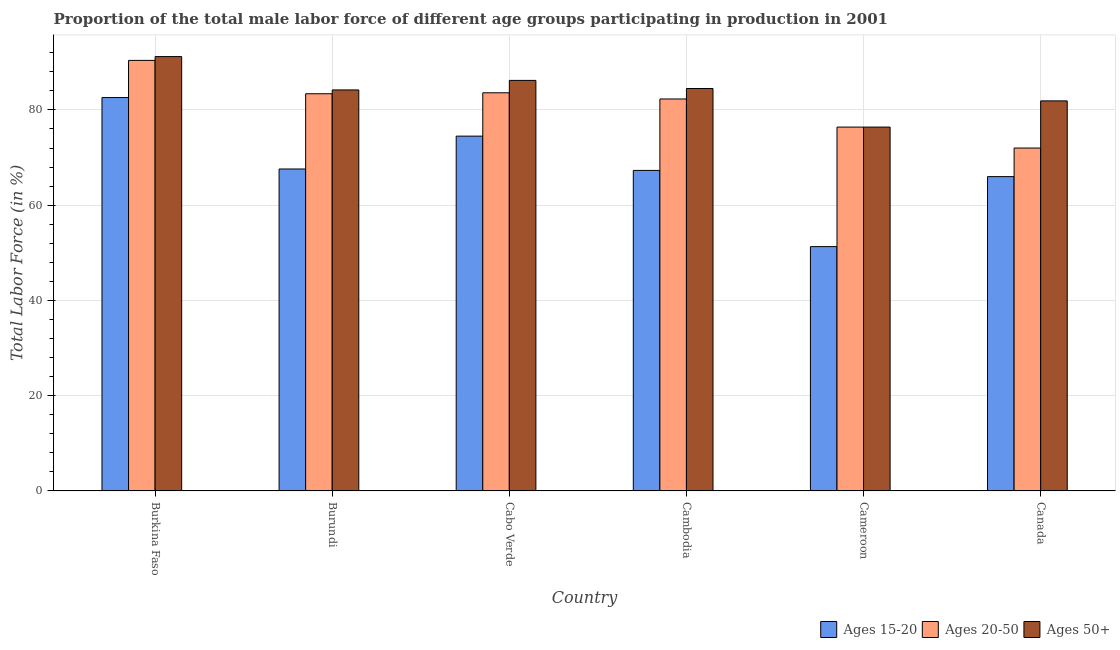How many groups of bars are there?
Provide a short and direct response. 6. What is the label of the 2nd group of bars from the left?
Keep it short and to the point. Burundi. In how many cases, is the number of bars for a given country not equal to the number of legend labels?
Ensure brevity in your answer.  0. What is the percentage of male labor force within the age group 15-20 in Cameroon?
Your answer should be very brief. 51.3. Across all countries, what is the maximum percentage of male labor force within the age group 15-20?
Offer a very short reply. 82.6. In which country was the percentage of male labor force within the age group 20-50 maximum?
Keep it short and to the point. Burkina Faso. In which country was the percentage of male labor force within the age group 15-20 minimum?
Keep it short and to the point. Cameroon. What is the total percentage of male labor force within the age group 20-50 in the graph?
Give a very brief answer. 488.1. What is the difference between the percentage of male labor force within the age group 15-20 in Burundi and that in Cameroon?
Offer a terse response. 16.3. What is the difference between the percentage of male labor force within the age group 15-20 in Burundi and the percentage of male labor force above age 50 in Cameroon?
Ensure brevity in your answer.  -8.8. What is the average percentage of male labor force within the age group 15-20 per country?
Ensure brevity in your answer.  68.22. What is the difference between the percentage of male labor force above age 50 and percentage of male labor force within the age group 15-20 in Canada?
Offer a very short reply. 15.9. In how many countries, is the percentage of male labor force within the age group 15-20 greater than 20 %?
Your answer should be compact. 6. What is the ratio of the percentage of male labor force within the age group 15-20 in Cameroon to that in Canada?
Offer a terse response. 0.78. What is the difference between the highest and the lowest percentage of male labor force above age 50?
Ensure brevity in your answer.  14.8. What does the 3rd bar from the left in Burkina Faso represents?
Keep it short and to the point. Ages 50+. What does the 2nd bar from the right in Canada represents?
Ensure brevity in your answer.  Ages 20-50. Is it the case that in every country, the sum of the percentage of male labor force within the age group 15-20 and percentage of male labor force within the age group 20-50 is greater than the percentage of male labor force above age 50?
Offer a very short reply. Yes. How many bars are there?
Provide a succinct answer. 18. What is the difference between two consecutive major ticks on the Y-axis?
Ensure brevity in your answer.  20. Where does the legend appear in the graph?
Your response must be concise. Bottom right. What is the title of the graph?
Provide a short and direct response. Proportion of the total male labor force of different age groups participating in production in 2001. Does "Unemployment benefits" appear as one of the legend labels in the graph?
Provide a succinct answer. No. What is the label or title of the X-axis?
Your answer should be very brief. Country. What is the label or title of the Y-axis?
Your answer should be very brief. Total Labor Force (in %). What is the Total Labor Force (in %) in Ages 15-20 in Burkina Faso?
Your answer should be very brief. 82.6. What is the Total Labor Force (in %) of Ages 20-50 in Burkina Faso?
Give a very brief answer. 90.4. What is the Total Labor Force (in %) of Ages 50+ in Burkina Faso?
Offer a terse response. 91.2. What is the Total Labor Force (in %) in Ages 15-20 in Burundi?
Keep it short and to the point. 67.6. What is the Total Labor Force (in %) in Ages 20-50 in Burundi?
Make the answer very short. 83.4. What is the Total Labor Force (in %) of Ages 50+ in Burundi?
Your response must be concise. 84.2. What is the Total Labor Force (in %) of Ages 15-20 in Cabo Verde?
Provide a short and direct response. 74.5. What is the Total Labor Force (in %) in Ages 20-50 in Cabo Verde?
Your answer should be very brief. 83.6. What is the Total Labor Force (in %) of Ages 50+ in Cabo Verde?
Provide a succinct answer. 86.2. What is the Total Labor Force (in %) in Ages 15-20 in Cambodia?
Offer a terse response. 67.3. What is the Total Labor Force (in %) of Ages 20-50 in Cambodia?
Ensure brevity in your answer.  82.3. What is the Total Labor Force (in %) of Ages 50+ in Cambodia?
Provide a succinct answer. 84.5. What is the Total Labor Force (in %) of Ages 15-20 in Cameroon?
Your answer should be compact. 51.3. What is the Total Labor Force (in %) in Ages 20-50 in Cameroon?
Your response must be concise. 76.4. What is the Total Labor Force (in %) in Ages 50+ in Cameroon?
Ensure brevity in your answer.  76.4. What is the Total Labor Force (in %) in Ages 20-50 in Canada?
Provide a succinct answer. 72. What is the Total Labor Force (in %) in Ages 50+ in Canada?
Your answer should be very brief. 81.9. Across all countries, what is the maximum Total Labor Force (in %) in Ages 15-20?
Make the answer very short. 82.6. Across all countries, what is the maximum Total Labor Force (in %) in Ages 20-50?
Your response must be concise. 90.4. Across all countries, what is the maximum Total Labor Force (in %) of Ages 50+?
Keep it short and to the point. 91.2. Across all countries, what is the minimum Total Labor Force (in %) in Ages 15-20?
Make the answer very short. 51.3. Across all countries, what is the minimum Total Labor Force (in %) of Ages 50+?
Your answer should be compact. 76.4. What is the total Total Labor Force (in %) of Ages 15-20 in the graph?
Offer a terse response. 409.3. What is the total Total Labor Force (in %) of Ages 20-50 in the graph?
Your answer should be compact. 488.1. What is the total Total Labor Force (in %) of Ages 50+ in the graph?
Provide a short and direct response. 504.4. What is the difference between the Total Labor Force (in %) of Ages 15-20 in Burkina Faso and that in Burundi?
Provide a short and direct response. 15. What is the difference between the Total Labor Force (in %) in Ages 50+ in Burkina Faso and that in Burundi?
Provide a short and direct response. 7. What is the difference between the Total Labor Force (in %) of Ages 15-20 in Burkina Faso and that in Cabo Verde?
Give a very brief answer. 8.1. What is the difference between the Total Labor Force (in %) of Ages 20-50 in Burkina Faso and that in Cabo Verde?
Give a very brief answer. 6.8. What is the difference between the Total Labor Force (in %) of Ages 15-20 in Burkina Faso and that in Cameroon?
Keep it short and to the point. 31.3. What is the difference between the Total Labor Force (in %) in Ages 20-50 in Burkina Faso and that in Cameroon?
Ensure brevity in your answer.  14. What is the difference between the Total Labor Force (in %) of Ages 15-20 in Burkina Faso and that in Canada?
Offer a terse response. 16.6. What is the difference between the Total Labor Force (in %) of Ages 50+ in Burkina Faso and that in Canada?
Make the answer very short. 9.3. What is the difference between the Total Labor Force (in %) of Ages 20-50 in Burundi and that in Cabo Verde?
Your response must be concise. -0.2. What is the difference between the Total Labor Force (in %) in Ages 50+ in Burundi and that in Cabo Verde?
Provide a succinct answer. -2. What is the difference between the Total Labor Force (in %) of Ages 20-50 in Burundi and that in Cambodia?
Your answer should be very brief. 1.1. What is the difference between the Total Labor Force (in %) of Ages 50+ in Burundi and that in Cambodia?
Your answer should be very brief. -0.3. What is the difference between the Total Labor Force (in %) of Ages 20-50 in Burundi and that in Cameroon?
Provide a short and direct response. 7. What is the difference between the Total Labor Force (in %) in Ages 50+ in Burundi and that in Cameroon?
Your response must be concise. 7.8. What is the difference between the Total Labor Force (in %) of Ages 20-50 in Burundi and that in Canada?
Your answer should be compact. 11.4. What is the difference between the Total Labor Force (in %) in Ages 20-50 in Cabo Verde and that in Cambodia?
Your response must be concise. 1.3. What is the difference between the Total Labor Force (in %) of Ages 50+ in Cabo Verde and that in Cambodia?
Your response must be concise. 1.7. What is the difference between the Total Labor Force (in %) of Ages 15-20 in Cabo Verde and that in Cameroon?
Give a very brief answer. 23.2. What is the difference between the Total Labor Force (in %) in Ages 20-50 in Cabo Verde and that in Cameroon?
Your answer should be very brief. 7.2. What is the difference between the Total Labor Force (in %) in Ages 15-20 in Cabo Verde and that in Canada?
Keep it short and to the point. 8.5. What is the difference between the Total Labor Force (in %) of Ages 20-50 in Cabo Verde and that in Canada?
Your answer should be compact. 11.6. What is the difference between the Total Labor Force (in %) in Ages 50+ in Cambodia and that in Cameroon?
Provide a short and direct response. 8.1. What is the difference between the Total Labor Force (in %) of Ages 15-20 in Cambodia and that in Canada?
Ensure brevity in your answer.  1.3. What is the difference between the Total Labor Force (in %) in Ages 50+ in Cambodia and that in Canada?
Offer a very short reply. 2.6. What is the difference between the Total Labor Force (in %) in Ages 15-20 in Cameroon and that in Canada?
Give a very brief answer. -14.7. What is the difference between the Total Labor Force (in %) in Ages 50+ in Cameroon and that in Canada?
Provide a succinct answer. -5.5. What is the difference between the Total Labor Force (in %) in Ages 15-20 in Burkina Faso and the Total Labor Force (in %) in Ages 20-50 in Burundi?
Your answer should be very brief. -0.8. What is the difference between the Total Labor Force (in %) in Ages 20-50 in Burkina Faso and the Total Labor Force (in %) in Ages 50+ in Burundi?
Your response must be concise. 6.2. What is the difference between the Total Labor Force (in %) of Ages 15-20 in Burkina Faso and the Total Labor Force (in %) of Ages 50+ in Cabo Verde?
Keep it short and to the point. -3.6. What is the difference between the Total Labor Force (in %) of Ages 15-20 in Burkina Faso and the Total Labor Force (in %) of Ages 50+ in Cambodia?
Your answer should be very brief. -1.9. What is the difference between the Total Labor Force (in %) of Ages 20-50 in Burkina Faso and the Total Labor Force (in %) of Ages 50+ in Cambodia?
Provide a succinct answer. 5.9. What is the difference between the Total Labor Force (in %) in Ages 15-20 in Burkina Faso and the Total Labor Force (in %) in Ages 20-50 in Cameroon?
Give a very brief answer. 6.2. What is the difference between the Total Labor Force (in %) of Ages 15-20 in Burkina Faso and the Total Labor Force (in %) of Ages 50+ in Cameroon?
Your answer should be very brief. 6.2. What is the difference between the Total Labor Force (in %) in Ages 20-50 in Burkina Faso and the Total Labor Force (in %) in Ages 50+ in Cameroon?
Your answer should be very brief. 14. What is the difference between the Total Labor Force (in %) in Ages 15-20 in Burkina Faso and the Total Labor Force (in %) in Ages 20-50 in Canada?
Your answer should be compact. 10.6. What is the difference between the Total Labor Force (in %) of Ages 15-20 in Burkina Faso and the Total Labor Force (in %) of Ages 50+ in Canada?
Offer a terse response. 0.7. What is the difference between the Total Labor Force (in %) in Ages 20-50 in Burkina Faso and the Total Labor Force (in %) in Ages 50+ in Canada?
Offer a very short reply. 8.5. What is the difference between the Total Labor Force (in %) in Ages 15-20 in Burundi and the Total Labor Force (in %) in Ages 50+ in Cabo Verde?
Offer a very short reply. -18.6. What is the difference between the Total Labor Force (in %) of Ages 20-50 in Burundi and the Total Labor Force (in %) of Ages 50+ in Cabo Verde?
Make the answer very short. -2.8. What is the difference between the Total Labor Force (in %) of Ages 15-20 in Burundi and the Total Labor Force (in %) of Ages 20-50 in Cambodia?
Provide a succinct answer. -14.7. What is the difference between the Total Labor Force (in %) of Ages 15-20 in Burundi and the Total Labor Force (in %) of Ages 50+ in Cambodia?
Provide a short and direct response. -16.9. What is the difference between the Total Labor Force (in %) of Ages 20-50 in Burundi and the Total Labor Force (in %) of Ages 50+ in Cameroon?
Provide a succinct answer. 7. What is the difference between the Total Labor Force (in %) of Ages 15-20 in Burundi and the Total Labor Force (in %) of Ages 50+ in Canada?
Offer a very short reply. -14.3. What is the difference between the Total Labor Force (in %) of Ages 15-20 in Cabo Verde and the Total Labor Force (in %) of Ages 50+ in Cambodia?
Make the answer very short. -10. What is the difference between the Total Labor Force (in %) in Ages 15-20 in Cabo Verde and the Total Labor Force (in %) in Ages 50+ in Cameroon?
Offer a very short reply. -1.9. What is the difference between the Total Labor Force (in %) of Ages 20-50 in Cabo Verde and the Total Labor Force (in %) of Ages 50+ in Cameroon?
Provide a succinct answer. 7.2. What is the difference between the Total Labor Force (in %) in Ages 15-20 in Cabo Verde and the Total Labor Force (in %) in Ages 20-50 in Canada?
Ensure brevity in your answer.  2.5. What is the difference between the Total Labor Force (in %) of Ages 15-20 in Cabo Verde and the Total Labor Force (in %) of Ages 50+ in Canada?
Give a very brief answer. -7.4. What is the difference between the Total Labor Force (in %) of Ages 20-50 in Cabo Verde and the Total Labor Force (in %) of Ages 50+ in Canada?
Offer a terse response. 1.7. What is the difference between the Total Labor Force (in %) in Ages 15-20 in Cambodia and the Total Labor Force (in %) in Ages 50+ in Cameroon?
Offer a terse response. -9.1. What is the difference between the Total Labor Force (in %) of Ages 20-50 in Cambodia and the Total Labor Force (in %) of Ages 50+ in Cameroon?
Your response must be concise. 5.9. What is the difference between the Total Labor Force (in %) in Ages 15-20 in Cambodia and the Total Labor Force (in %) in Ages 20-50 in Canada?
Make the answer very short. -4.7. What is the difference between the Total Labor Force (in %) of Ages 15-20 in Cambodia and the Total Labor Force (in %) of Ages 50+ in Canada?
Give a very brief answer. -14.6. What is the difference between the Total Labor Force (in %) of Ages 20-50 in Cambodia and the Total Labor Force (in %) of Ages 50+ in Canada?
Provide a short and direct response. 0.4. What is the difference between the Total Labor Force (in %) in Ages 15-20 in Cameroon and the Total Labor Force (in %) in Ages 20-50 in Canada?
Your answer should be very brief. -20.7. What is the difference between the Total Labor Force (in %) of Ages 15-20 in Cameroon and the Total Labor Force (in %) of Ages 50+ in Canada?
Your answer should be very brief. -30.6. What is the average Total Labor Force (in %) of Ages 15-20 per country?
Provide a succinct answer. 68.22. What is the average Total Labor Force (in %) in Ages 20-50 per country?
Give a very brief answer. 81.35. What is the average Total Labor Force (in %) of Ages 50+ per country?
Your answer should be compact. 84.07. What is the difference between the Total Labor Force (in %) in Ages 15-20 and Total Labor Force (in %) in Ages 50+ in Burkina Faso?
Provide a short and direct response. -8.6. What is the difference between the Total Labor Force (in %) of Ages 20-50 and Total Labor Force (in %) of Ages 50+ in Burkina Faso?
Provide a succinct answer. -0.8. What is the difference between the Total Labor Force (in %) of Ages 15-20 and Total Labor Force (in %) of Ages 20-50 in Burundi?
Ensure brevity in your answer.  -15.8. What is the difference between the Total Labor Force (in %) of Ages 15-20 and Total Labor Force (in %) of Ages 50+ in Burundi?
Your response must be concise. -16.6. What is the difference between the Total Labor Force (in %) of Ages 20-50 and Total Labor Force (in %) of Ages 50+ in Cabo Verde?
Provide a short and direct response. -2.6. What is the difference between the Total Labor Force (in %) of Ages 15-20 and Total Labor Force (in %) of Ages 50+ in Cambodia?
Offer a terse response. -17.2. What is the difference between the Total Labor Force (in %) in Ages 20-50 and Total Labor Force (in %) in Ages 50+ in Cambodia?
Your response must be concise. -2.2. What is the difference between the Total Labor Force (in %) in Ages 15-20 and Total Labor Force (in %) in Ages 20-50 in Cameroon?
Offer a terse response. -25.1. What is the difference between the Total Labor Force (in %) in Ages 15-20 and Total Labor Force (in %) in Ages 50+ in Cameroon?
Your answer should be compact. -25.1. What is the difference between the Total Labor Force (in %) of Ages 15-20 and Total Labor Force (in %) of Ages 50+ in Canada?
Make the answer very short. -15.9. What is the ratio of the Total Labor Force (in %) in Ages 15-20 in Burkina Faso to that in Burundi?
Give a very brief answer. 1.22. What is the ratio of the Total Labor Force (in %) of Ages 20-50 in Burkina Faso to that in Burundi?
Provide a short and direct response. 1.08. What is the ratio of the Total Labor Force (in %) in Ages 50+ in Burkina Faso to that in Burundi?
Offer a terse response. 1.08. What is the ratio of the Total Labor Force (in %) of Ages 15-20 in Burkina Faso to that in Cabo Verde?
Ensure brevity in your answer.  1.11. What is the ratio of the Total Labor Force (in %) of Ages 20-50 in Burkina Faso to that in Cabo Verde?
Make the answer very short. 1.08. What is the ratio of the Total Labor Force (in %) of Ages 50+ in Burkina Faso to that in Cabo Verde?
Make the answer very short. 1.06. What is the ratio of the Total Labor Force (in %) in Ages 15-20 in Burkina Faso to that in Cambodia?
Offer a terse response. 1.23. What is the ratio of the Total Labor Force (in %) in Ages 20-50 in Burkina Faso to that in Cambodia?
Give a very brief answer. 1.1. What is the ratio of the Total Labor Force (in %) in Ages 50+ in Burkina Faso to that in Cambodia?
Provide a short and direct response. 1.08. What is the ratio of the Total Labor Force (in %) of Ages 15-20 in Burkina Faso to that in Cameroon?
Offer a terse response. 1.61. What is the ratio of the Total Labor Force (in %) of Ages 20-50 in Burkina Faso to that in Cameroon?
Your response must be concise. 1.18. What is the ratio of the Total Labor Force (in %) of Ages 50+ in Burkina Faso to that in Cameroon?
Your answer should be very brief. 1.19. What is the ratio of the Total Labor Force (in %) in Ages 15-20 in Burkina Faso to that in Canada?
Provide a succinct answer. 1.25. What is the ratio of the Total Labor Force (in %) of Ages 20-50 in Burkina Faso to that in Canada?
Your answer should be compact. 1.26. What is the ratio of the Total Labor Force (in %) of Ages 50+ in Burkina Faso to that in Canada?
Your answer should be compact. 1.11. What is the ratio of the Total Labor Force (in %) in Ages 15-20 in Burundi to that in Cabo Verde?
Your answer should be compact. 0.91. What is the ratio of the Total Labor Force (in %) in Ages 20-50 in Burundi to that in Cabo Verde?
Keep it short and to the point. 1. What is the ratio of the Total Labor Force (in %) in Ages 50+ in Burundi to that in Cabo Verde?
Provide a short and direct response. 0.98. What is the ratio of the Total Labor Force (in %) in Ages 20-50 in Burundi to that in Cambodia?
Your response must be concise. 1.01. What is the ratio of the Total Labor Force (in %) in Ages 15-20 in Burundi to that in Cameroon?
Keep it short and to the point. 1.32. What is the ratio of the Total Labor Force (in %) in Ages 20-50 in Burundi to that in Cameroon?
Keep it short and to the point. 1.09. What is the ratio of the Total Labor Force (in %) of Ages 50+ in Burundi to that in Cameroon?
Keep it short and to the point. 1.1. What is the ratio of the Total Labor Force (in %) in Ages 15-20 in Burundi to that in Canada?
Provide a short and direct response. 1.02. What is the ratio of the Total Labor Force (in %) of Ages 20-50 in Burundi to that in Canada?
Keep it short and to the point. 1.16. What is the ratio of the Total Labor Force (in %) of Ages 50+ in Burundi to that in Canada?
Give a very brief answer. 1.03. What is the ratio of the Total Labor Force (in %) of Ages 15-20 in Cabo Verde to that in Cambodia?
Give a very brief answer. 1.11. What is the ratio of the Total Labor Force (in %) of Ages 20-50 in Cabo Verde to that in Cambodia?
Your answer should be very brief. 1.02. What is the ratio of the Total Labor Force (in %) in Ages 50+ in Cabo Verde to that in Cambodia?
Provide a short and direct response. 1.02. What is the ratio of the Total Labor Force (in %) of Ages 15-20 in Cabo Verde to that in Cameroon?
Make the answer very short. 1.45. What is the ratio of the Total Labor Force (in %) in Ages 20-50 in Cabo Verde to that in Cameroon?
Give a very brief answer. 1.09. What is the ratio of the Total Labor Force (in %) in Ages 50+ in Cabo Verde to that in Cameroon?
Your answer should be very brief. 1.13. What is the ratio of the Total Labor Force (in %) of Ages 15-20 in Cabo Verde to that in Canada?
Your answer should be compact. 1.13. What is the ratio of the Total Labor Force (in %) in Ages 20-50 in Cabo Verde to that in Canada?
Provide a short and direct response. 1.16. What is the ratio of the Total Labor Force (in %) of Ages 50+ in Cabo Verde to that in Canada?
Keep it short and to the point. 1.05. What is the ratio of the Total Labor Force (in %) of Ages 15-20 in Cambodia to that in Cameroon?
Give a very brief answer. 1.31. What is the ratio of the Total Labor Force (in %) of Ages 20-50 in Cambodia to that in Cameroon?
Give a very brief answer. 1.08. What is the ratio of the Total Labor Force (in %) in Ages 50+ in Cambodia to that in Cameroon?
Keep it short and to the point. 1.11. What is the ratio of the Total Labor Force (in %) of Ages 15-20 in Cambodia to that in Canada?
Your answer should be very brief. 1.02. What is the ratio of the Total Labor Force (in %) of Ages 20-50 in Cambodia to that in Canada?
Keep it short and to the point. 1.14. What is the ratio of the Total Labor Force (in %) in Ages 50+ in Cambodia to that in Canada?
Your answer should be very brief. 1.03. What is the ratio of the Total Labor Force (in %) of Ages 15-20 in Cameroon to that in Canada?
Make the answer very short. 0.78. What is the ratio of the Total Labor Force (in %) in Ages 20-50 in Cameroon to that in Canada?
Offer a terse response. 1.06. What is the ratio of the Total Labor Force (in %) in Ages 50+ in Cameroon to that in Canada?
Your response must be concise. 0.93. What is the difference between the highest and the second highest Total Labor Force (in %) of Ages 15-20?
Keep it short and to the point. 8.1. What is the difference between the highest and the second highest Total Labor Force (in %) of Ages 20-50?
Give a very brief answer. 6.8. What is the difference between the highest and the second highest Total Labor Force (in %) of Ages 50+?
Make the answer very short. 5. What is the difference between the highest and the lowest Total Labor Force (in %) of Ages 15-20?
Provide a succinct answer. 31.3. What is the difference between the highest and the lowest Total Labor Force (in %) of Ages 50+?
Provide a succinct answer. 14.8. 